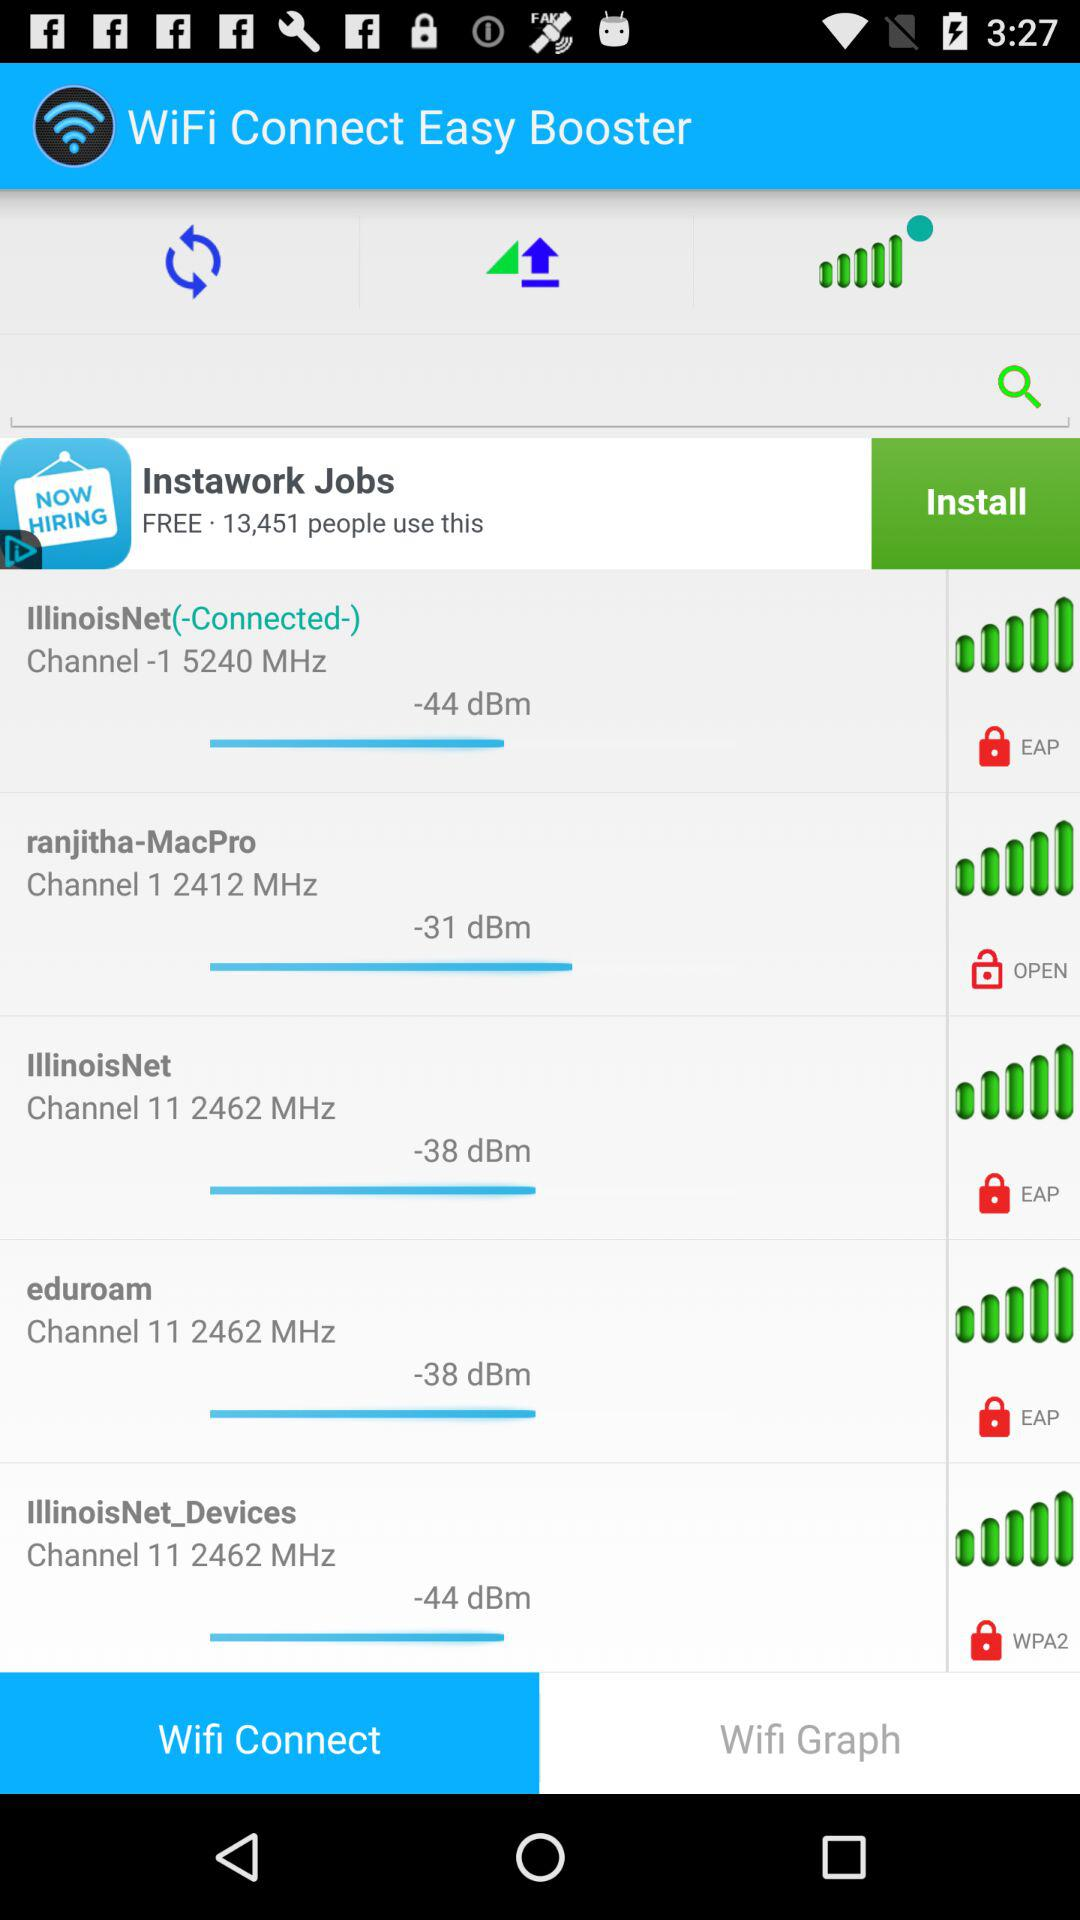What is the channel number of "ranjitha-MacPro"? The channel number of "ranjitha-MacPro" is 1. 